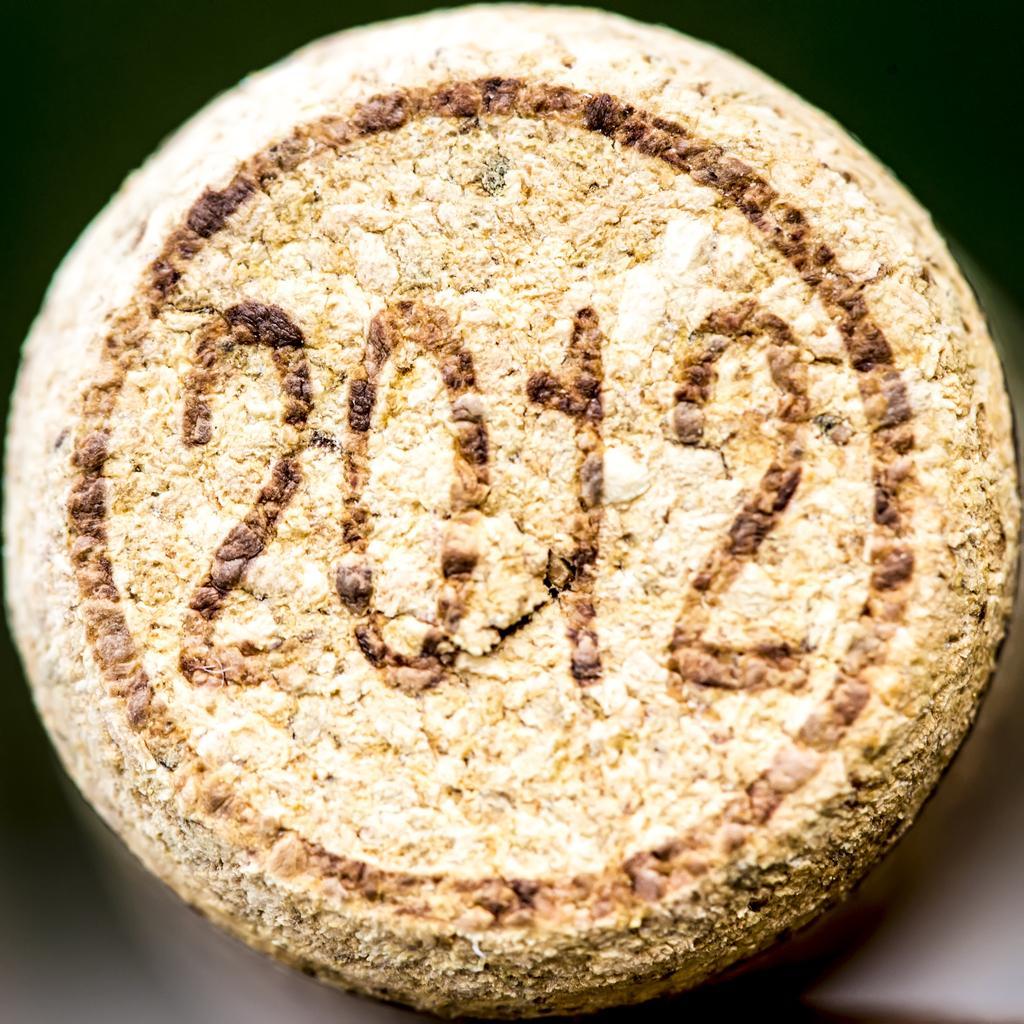Could you give a brief overview of what you see in this image? In this image we can see an object with some numbers on it. 